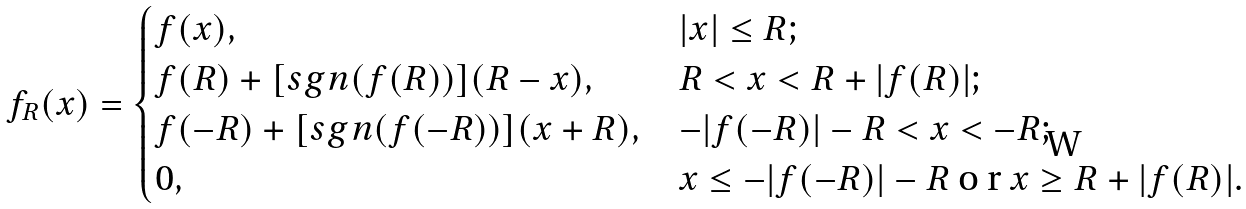Convert formula to latex. <formula><loc_0><loc_0><loc_500><loc_500>f _ { R } ( x ) = \begin{cases} f ( x ) , & | x | \leq R ; \\ f ( R ) + [ s g n ( f ( R ) ) ] ( R - x ) , & R < x < R + | f ( R ) | ; \\ f ( - R ) + [ s g n ( f ( - R ) ) ] ( x + R ) , & - | f ( - R ) | - R < x < - R ; \\ 0 , & x \leq - | f ( - R ) | - R $ o r $ x \geq R + | f ( R ) | . \\ \end{cases}</formula> 